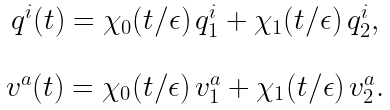Convert formula to latex. <formula><loc_0><loc_0><loc_500><loc_500>\begin{array} { c } q ^ { i } ( t ) = \chi _ { 0 } ( t / \epsilon ) \, q ^ { i } _ { 1 } + \chi _ { 1 } ( t / \epsilon ) \, q ^ { i } _ { 2 } , \\ \\ v ^ { a } ( t ) = \chi _ { 0 } ( t / \epsilon ) \, v ^ { a } _ { 1 } + \chi _ { 1 } ( t / \epsilon ) \, v ^ { a } _ { 2 } . \end{array}</formula> 